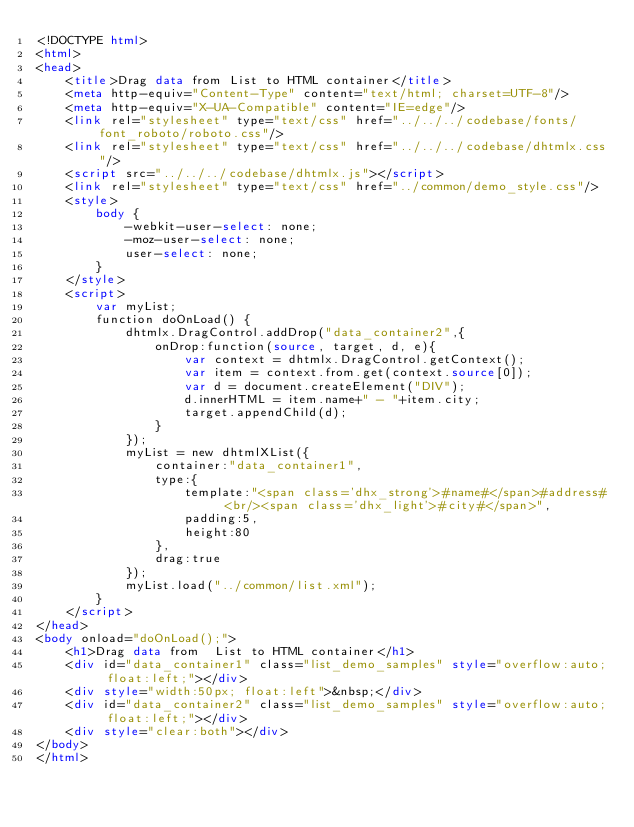<code> <loc_0><loc_0><loc_500><loc_500><_HTML_><!DOCTYPE html>
<html>
<head>
	<title>Drag data from List to HTML container</title>
	<meta http-equiv="Content-Type" content="text/html; charset=UTF-8"/>
	<meta http-equiv="X-UA-Compatible" content="IE=edge"/>
	<link rel="stylesheet" type="text/css" href="../../../codebase/fonts/font_roboto/roboto.css"/>
	<link rel="stylesheet" type="text/css" href="../../../codebase/dhtmlx.css"/>
	<script src="../../../codebase/dhtmlx.js"></script>
	<link rel="stylesheet" type="text/css" href="../common/demo_style.css"/>
	<style>
		body {
			-webkit-user-select: none;
			-moz-user-select: none;
			user-select: none;
		}
	</style>
	<script>
		var myList;
		function doOnLoad() {
			dhtmlx.DragControl.addDrop("data_container2",{
				onDrop:function(source, target, d, e){
					var context = dhtmlx.DragControl.getContext();
					var item = context.from.get(context.source[0]);
					var d = document.createElement("DIV");
					d.innerHTML = item.name+" - "+item.city;
					target.appendChild(d);
				}
			});
			myList = new dhtmlXList({
				container:"data_container1",
				type:{
					template:"<span class='dhx_strong'>#name#</span>#address# <br/><span class='dhx_light'>#city#</span>",
					padding:5,
					height:80
				},
				drag:true
			});
			myList.load("../common/list.xml");
		}
	</script>
</head>
<body onload="doOnLoad();">
	<h1>Drag data from  List to HTML container</h1>
	<div id="data_container1" class="list_demo_samples" style="overflow:auto; float:left;"></div>
	<div style="width:50px; float:left">&nbsp;</div>
	<div id="data_container2" class="list_demo_samples" style="overflow:auto; float:left;"></div>
	<div style="clear:both"></div>
</body>
</html>


</code> 